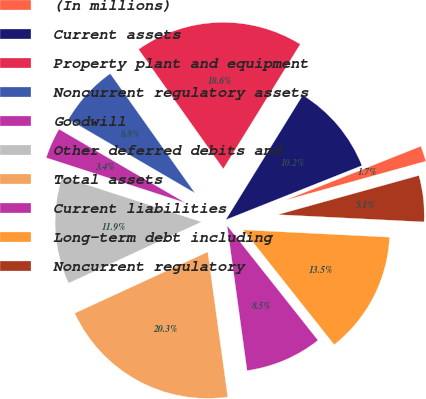Convert chart. <chart><loc_0><loc_0><loc_500><loc_500><pie_chart><fcel>(In millions)<fcel>Current assets<fcel>Property plant and equipment<fcel>Noncurrent regulatory assets<fcel>Goodwill<fcel>Other deferred debits and<fcel>Total assets<fcel>Current liabilities<fcel>Long-term debt including<fcel>Noncurrent regulatory<nl><fcel>1.72%<fcel>10.17%<fcel>18.62%<fcel>6.79%<fcel>3.41%<fcel>11.86%<fcel>20.31%<fcel>8.48%<fcel>13.55%<fcel>5.1%<nl></chart> 